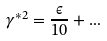Convert formula to latex. <formula><loc_0><loc_0><loc_500><loc_500>\gamma ^ { \ast 2 } = \frac { \epsilon } { 1 0 } + \dots</formula> 